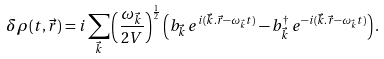<formula> <loc_0><loc_0><loc_500><loc_500>\delta \rho ( t , \vec { r } ) = i \sum _ { \vec { k } } \left ( \frac { \omega _ { \vec { k } } } { 2 V } \right ) ^ { \frac { 1 } { 2 } } \left ( b _ { \vec { k } } \, e ^ { i ( \vec { k } . \vec { r } - \omega _ { \vec { k } } t ) } - b _ { \vec { k } } ^ { \dagger } \, e ^ { - i ( \vec { k } . \vec { r } - \omega _ { \vec { k } } t ) } \right ) .</formula> 